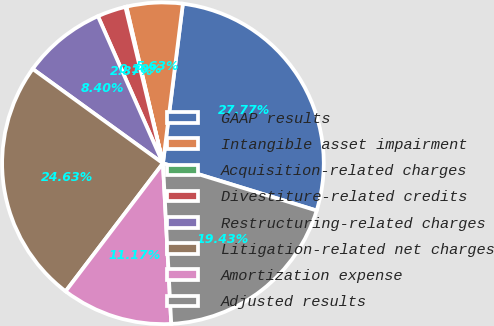Convert chart. <chart><loc_0><loc_0><loc_500><loc_500><pie_chart><fcel>GAAP results<fcel>Intangible asset impairment<fcel>Acquisition-related charges<fcel>Divestiture-related credits<fcel>Restructuring-related charges<fcel>Litigation-related net charges<fcel>Amortization expense<fcel>Adjusted results<nl><fcel>27.77%<fcel>5.63%<fcel>0.1%<fcel>2.87%<fcel>8.4%<fcel>24.63%<fcel>11.17%<fcel>19.43%<nl></chart> 